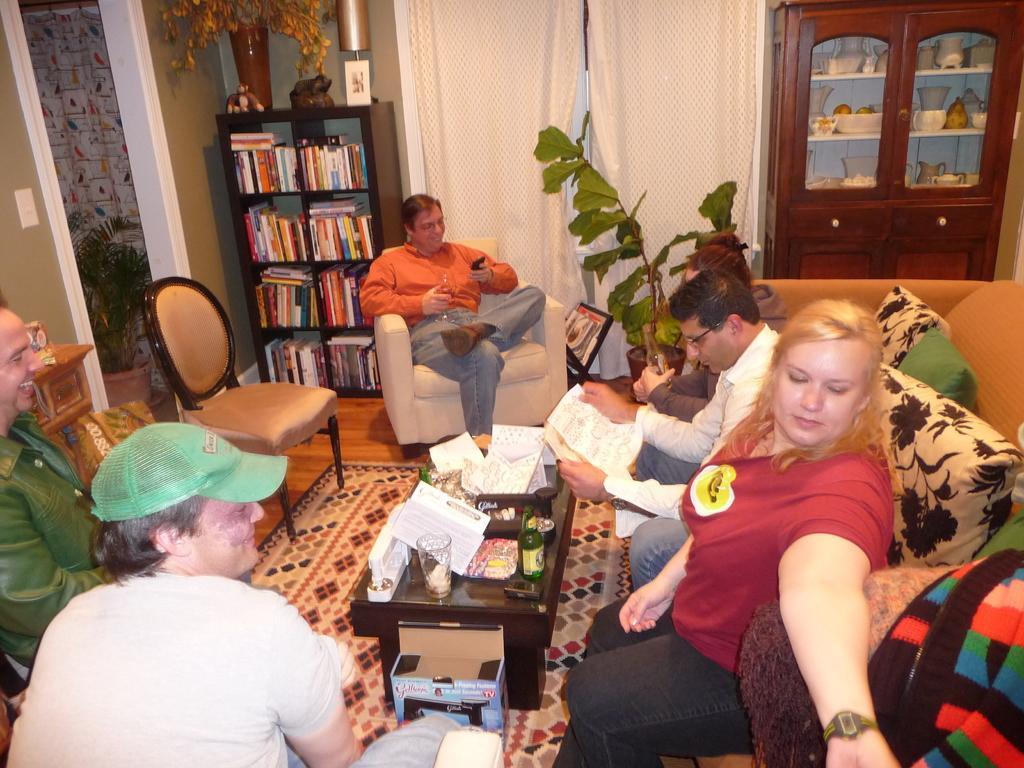In one or two sentences, can you explain what this image depicts? In a room there are some people sitting. To the right side there are three people sitting on the sofa. And the man with the orange shirt is sitting in the chair. There is another chair. To the left corner there are two men sitting. The is covered with many books. And we can see a pot. In middle there are some curtains. In the right side there is a cupboard with vessels in it. 